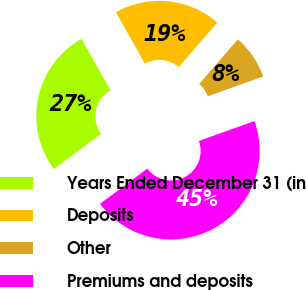Convert chart. <chart><loc_0><loc_0><loc_500><loc_500><pie_chart><fcel>Years Ended December 31 (in<fcel>Deposits<fcel>Other<fcel>Premiums and deposits<nl><fcel>27.07%<fcel>19.49%<fcel>8.17%<fcel>45.27%<nl></chart> 